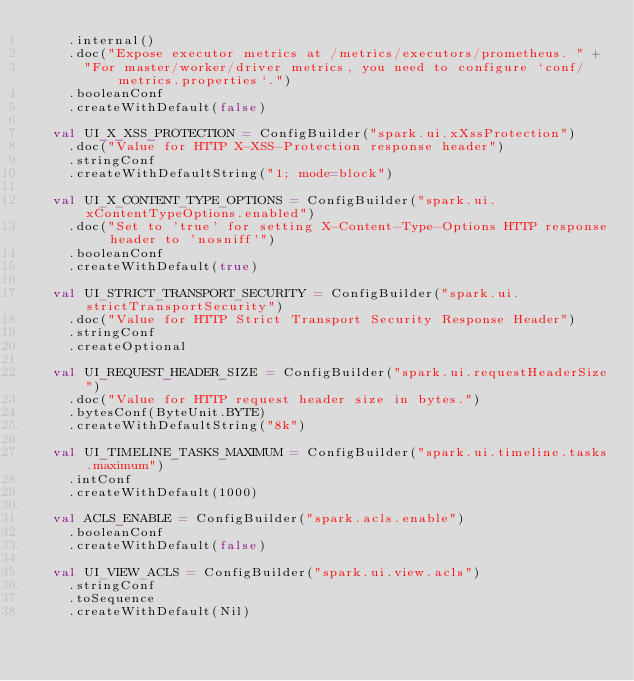<code> <loc_0><loc_0><loc_500><loc_500><_Scala_>    .internal()
    .doc("Expose executor metrics at /metrics/executors/prometheus. " +
      "For master/worker/driver metrics, you need to configure `conf/metrics.properties`.")
    .booleanConf
    .createWithDefault(false)

  val UI_X_XSS_PROTECTION = ConfigBuilder("spark.ui.xXssProtection")
    .doc("Value for HTTP X-XSS-Protection response header")
    .stringConf
    .createWithDefaultString("1; mode=block")

  val UI_X_CONTENT_TYPE_OPTIONS = ConfigBuilder("spark.ui.xContentTypeOptions.enabled")
    .doc("Set to 'true' for setting X-Content-Type-Options HTTP response header to 'nosniff'")
    .booleanConf
    .createWithDefault(true)

  val UI_STRICT_TRANSPORT_SECURITY = ConfigBuilder("spark.ui.strictTransportSecurity")
    .doc("Value for HTTP Strict Transport Security Response Header")
    .stringConf
    .createOptional

  val UI_REQUEST_HEADER_SIZE = ConfigBuilder("spark.ui.requestHeaderSize")
    .doc("Value for HTTP request header size in bytes.")
    .bytesConf(ByteUnit.BYTE)
    .createWithDefaultString("8k")

  val UI_TIMELINE_TASKS_MAXIMUM = ConfigBuilder("spark.ui.timeline.tasks.maximum")
    .intConf
    .createWithDefault(1000)

  val ACLS_ENABLE = ConfigBuilder("spark.acls.enable")
    .booleanConf
    .createWithDefault(false)

  val UI_VIEW_ACLS = ConfigBuilder("spark.ui.view.acls")
    .stringConf
    .toSequence
    .createWithDefault(Nil)
</code> 